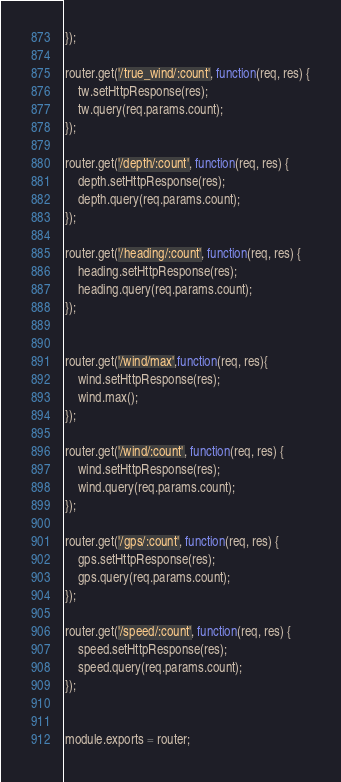<code> <loc_0><loc_0><loc_500><loc_500><_JavaScript_>});

router.get('/true_wind/:count', function(req, res) {
	tw.setHttpResponse(res);
	tw.query(req.params.count);
});

router.get('/depth/:count', function(req, res) {
	depth.setHttpResponse(res);
	depth.query(req.params.count);
});

router.get('/heading/:count', function(req, res) {
	heading.setHttpResponse(res);
	heading.query(req.params.count);
});


router.get('/wind/max',function(req, res){
	wind.setHttpResponse(res);
	wind.max();
});

router.get('/wind/:count', function(req, res) {
	wind.setHttpResponse(res);
	wind.query(req.params.count);
});

router.get('/gps/:count', function(req, res) {
	gps.setHttpResponse(res);
	gps.query(req.params.count);
});

router.get('/speed/:count', function(req, res) {
	speed.setHttpResponse(res);
	speed.query(req.params.count);
});


module.exports = router;
</code> 